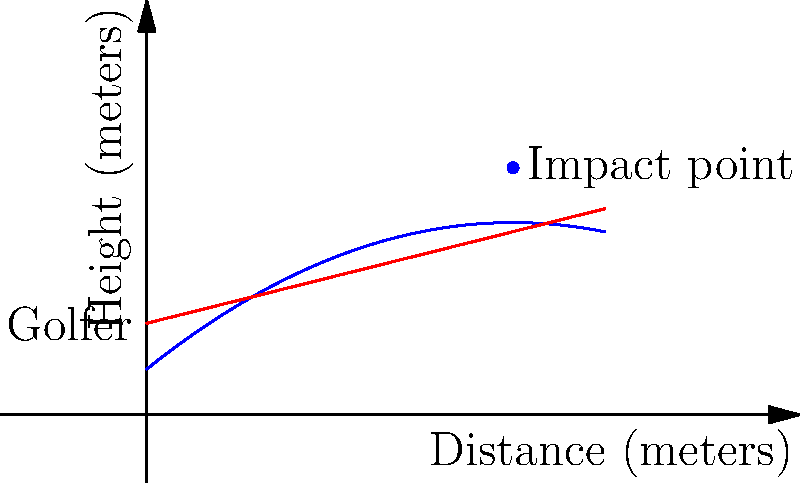As a professional golf enthusiast, you're analyzing the trajectory of a golf ball. The ball's path can be modeled by the parabolic function $f(x) = -0.05x^2 + 0.8x + 1$, where $x$ is the horizontal distance and $f(x)$ is the height, both measured in meters. Your line of sight follows the linear function $g(x) = 0.25x + 2$. At what horizontal distance does the golf ball's trajectory intersect with your line of sight? To find the intersection point, we need to solve the equation:

$f(x) = g(x)$

Substituting the given functions:

$-0.05x^2 + 0.8x + 1 = 0.25x + 2$

Rearranging the equation:

$-0.05x^2 + 0.55x - 1 = 0$

This is a quadratic equation in the form $ax^2 + bx + c = 0$, where:
$a = -0.05$
$b = 0.55$
$c = -1$

We can solve this using the quadratic formula: $x = \frac{-b \pm \sqrt{b^2 - 4ac}}{2a}$

Substituting the values:

$x = \frac{-0.55 \pm \sqrt{0.55^2 - 4(-0.05)(-1)}}{2(-0.05)}$

$x = \frac{-0.55 \pm \sqrt{0.3025 - 0.2}}{-0.1}$

$x = \frac{-0.55 \pm \sqrt{0.1025}}{-0.1}$

$x = \frac{-0.55 \pm 0.32}{-0.1}$

This gives us two solutions:
$x_1 = \frac{-0.55 + 0.32}{-0.1} = 2.3$ meters
$x_2 = \frac{-0.55 - 0.32}{-0.1} = 8.7$ meters

The golf ball intersects the line of sight at two points. However, the question asks for the horizontal distance, which is the second intersection point at approximately 8.7 meters.
Answer: 8.7 meters 